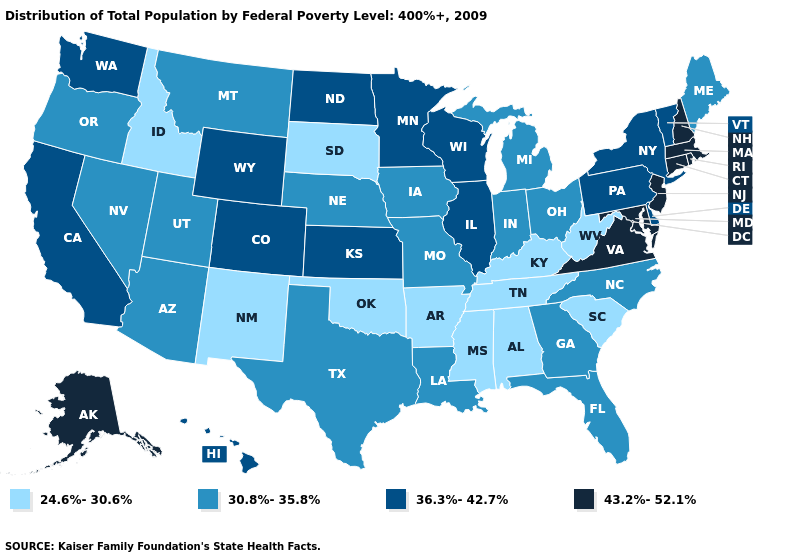Does Maine have the lowest value in the Northeast?
Be succinct. Yes. Name the states that have a value in the range 24.6%-30.6%?
Be succinct. Alabama, Arkansas, Idaho, Kentucky, Mississippi, New Mexico, Oklahoma, South Carolina, South Dakota, Tennessee, West Virginia. Which states have the highest value in the USA?
Concise answer only. Alaska, Connecticut, Maryland, Massachusetts, New Hampshire, New Jersey, Rhode Island, Virginia. Does Massachusetts have the highest value in the USA?
Be succinct. Yes. Does New Jersey have the highest value in the USA?
Answer briefly. Yes. Among the states that border Oregon , does Nevada have the highest value?
Give a very brief answer. No. What is the lowest value in the Northeast?
Write a very short answer. 30.8%-35.8%. What is the highest value in states that border Nebraska?
Concise answer only. 36.3%-42.7%. Name the states that have a value in the range 30.8%-35.8%?
Write a very short answer. Arizona, Florida, Georgia, Indiana, Iowa, Louisiana, Maine, Michigan, Missouri, Montana, Nebraska, Nevada, North Carolina, Ohio, Oregon, Texas, Utah. What is the lowest value in states that border Maryland?
Write a very short answer. 24.6%-30.6%. Which states have the lowest value in the South?
Write a very short answer. Alabama, Arkansas, Kentucky, Mississippi, Oklahoma, South Carolina, Tennessee, West Virginia. Which states have the lowest value in the USA?
Write a very short answer. Alabama, Arkansas, Idaho, Kentucky, Mississippi, New Mexico, Oklahoma, South Carolina, South Dakota, Tennessee, West Virginia. Among the states that border Louisiana , does Texas have the highest value?
Give a very brief answer. Yes. What is the value of Indiana?
Concise answer only. 30.8%-35.8%. Among the states that border Mississippi , does Louisiana have the highest value?
Keep it brief. Yes. 